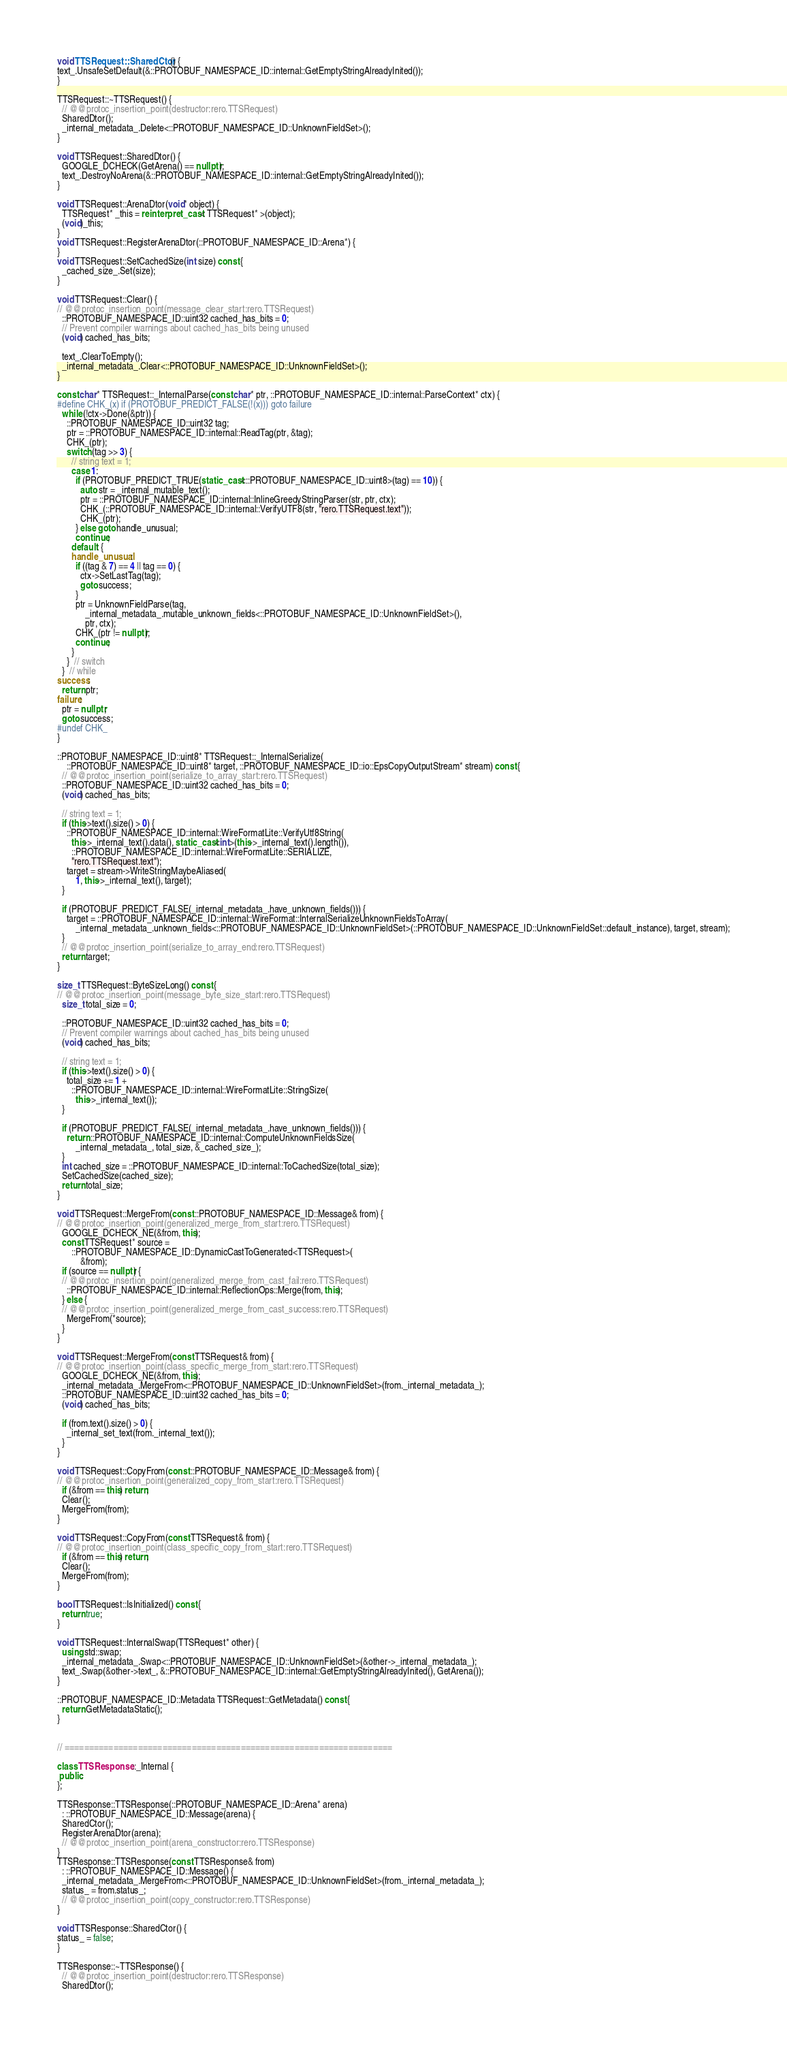Convert code to text. <code><loc_0><loc_0><loc_500><loc_500><_C++_>
void TTSRequest::SharedCtor() {
text_.UnsafeSetDefault(&::PROTOBUF_NAMESPACE_ID::internal::GetEmptyStringAlreadyInited());
}

TTSRequest::~TTSRequest() {
  // @@protoc_insertion_point(destructor:rero.TTSRequest)
  SharedDtor();
  _internal_metadata_.Delete<::PROTOBUF_NAMESPACE_ID::UnknownFieldSet>();
}

void TTSRequest::SharedDtor() {
  GOOGLE_DCHECK(GetArena() == nullptr);
  text_.DestroyNoArena(&::PROTOBUF_NAMESPACE_ID::internal::GetEmptyStringAlreadyInited());
}

void TTSRequest::ArenaDtor(void* object) {
  TTSRequest* _this = reinterpret_cast< TTSRequest* >(object);
  (void)_this;
}
void TTSRequest::RegisterArenaDtor(::PROTOBUF_NAMESPACE_ID::Arena*) {
}
void TTSRequest::SetCachedSize(int size) const {
  _cached_size_.Set(size);
}

void TTSRequest::Clear() {
// @@protoc_insertion_point(message_clear_start:rero.TTSRequest)
  ::PROTOBUF_NAMESPACE_ID::uint32 cached_has_bits = 0;
  // Prevent compiler warnings about cached_has_bits being unused
  (void) cached_has_bits;

  text_.ClearToEmpty();
  _internal_metadata_.Clear<::PROTOBUF_NAMESPACE_ID::UnknownFieldSet>();
}

const char* TTSRequest::_InternalParse(const char* ptr, ::PROTOBUF_NAMESPACE_ID::internal::ParseContext* ctx) {
#define CHK_(x) if (PROTOBUF_PREDICT_FALSE(!(x))) goto failure
  while (!ctx->Done(&ptr)) {
    ::PROTOBUF_NAMESPACE_ID::uint32 tag;
    ptr = ::PROTOBUF_NAMESPACE_ID::internal::ReadTag(ptr, &tag);
    CHK_(ptr);
    switch (tag >> 3) {
      // string text = 1;
      case 1:
        if (PROTOBUF_PREDICT_TRUE(static_cast<::PROTOBUF_NAMESPACE_ID::uint8>(tag) == 10)) {
          auto str = _internal_mutable_text();
          ptr = ::PROTOBUF_NAMESPACE_ID::internal::InlineGreedyStringParser(str, ptr, ctx);
          CHK_(::PROTOBUF_NAMESPACE_ID::internal::VerifyUTF8(str, "rero.TTSRequest.text"));
          CHK_(ptr);
        } else goto handle_unusual;
        continue;
      default: {
      handle_unusual:
        if ((tag & 7) == 4 || tag == 0) {
          ctx->SetLastTag(tag);
          goto success;
        }
        ptr = UnknownFieldParse(tag,
            _internal_metadata_.mutable_unknown_fields<::PROTOBUF_NAMESPACE_ID::UnknownFieldSet>(),
            ptr, ctx);
        CHK_(ptr != nullptr);
        continue;
      }
    }  // switch
  }  // while
success:
  return ptr;
failure:
  ptr = nullptr;
  goto success;
#undef CHK_
}

::PROTOBUF_NAMESPACE_ID::uint8* TTSRequest::_InternalSerialize(
    ::PROTOBUF_NAMESPACE_ID::uint8* target, ::PROTOBUF_NAMESPACE_ID::io::EpsCopyOutputStream* stream) const {
  // @@protoc_insertion_point(serialize_to_array_start:rero.TTSRequest)
  ::PROTOBUF_NAMESPACE_ID::uint32 cached_has_bits = 0;
  (void) cached_has_bits;

  // string text = 1;
  if (this->text().size() > 0) {
    ::PROTOBUF_NAMESPACE_ID::internal::WireFormatLite::VerifyUtf8String(
      this->_internal_text().data(), static_cast<int>(this->_internal_text().length()),
      ::PROTOBUF_NAMESPACE_ID::internal::WireFormatLite::SERIALIZE,
      "rero.TTSRequest.text");
    target = stream->WriteStringMaybeAliased(
        1, this->_internal_text(), target);
  }

  if (PROTOBUF_PREDICT_FALSE(_internal_metadata_.have_unknown_fields())) {
    target = ::PROTOBUF_NAMESPACE_ID::internal::WireFormat::InternalSerializeUnknownFieldsToArray(
        _internal_metadata_.unknown_fields<::PROTOBUF_NAMESPACE_ID::UnknownFieldSet>(::PROTOBUF_NAMESPACE_ID::UnknownFieldSet::default_instance), target, stream);
  }
  // @@protoc_insertion_point(serialize_to_array_end:rero.TTSRequest)
  return target;
}

size_t TTSRequest::ByteSizeLong() const {
// @@protoc_insertion_point(message_byte_size_start:rero.TTSRequest)
  size_t total_size = 0;

  ::PROTOBUF_NAMESPACE_ID::uint32 cached_has_bits = 0;
  // Prevent compiler warnings about cached_has_bits being unused
  (void) cached_has_bits;

  // string text = 1;
  if (this->text().size() > 0) {
    total_size += 1 +
      ::PROTOBUF_NAMESPACE_ID::internal::WireFormatLite::StringSize(
        this->_internal_text());
  }

  if (PROTOBUF_PREDICT_FALSE(_internal_metadata_.have_unknown_fields())) {
    return ::PROTOBUF_NAMESPACE_ID::internal::ComputeUnknownFieldsSize(
        _internal_metadata_, total_size, &_cached_size_);
  }
  int cached_size = ::PROTOBUF_NAMESPACE_ID::internal::ToCachedSize(total_size);
  SetCachedSize(cached_size);
  return total_size;
}

void TTSRequest::MergeFrom(const ::PROTOBUF_NAMESPACE_ID::Message& from) {
// @@protoc_insertion_point(generalized_merge_from_start:rero.TTSRequest)
  GOOGLE_DCHECK_NE(&from, this);
  const TTSRequest* source =
      ::PROTOBUF_NAMESPACE_ID::DynamicCastToGenerated<TTSRequest>(
          &from);
  if (source == nullptr) {
  // @@protoc_insertion_point(generalized_merge_from_cast_fail:rero.TTSRequest)
    ::PROTOBUF_NAMESPACE_ID::internal::ReflectionOps::Merge(from, this);
  } else {
  // @@protoc_insertion_point(generalized_merge_from_cast_success:rero.TTSRequest)
    MergeFrom(*source);
  }
}

void TTSRequest::MergeFrom(const TTSRequest& from) {
// @@protoc_insertion_point(class_specific_merge_from_start:rero.TTSRequest)
  GOOGLE_DCHECK_NE(&from, this);
  _internal_metadata_.MergeFrom<::PROTOBUF_NAMESPACE_ID::UnknownFieldSet>(from._internal_metadata_);
  ::PROTOBUF_NAMESPACE_ID::uint32 cached_has_bits = 0;
  (void) cached_has_bits;

  if (from.text().size() > 0) {
    _internal_set_text(from._internal_text());
  }
}

void TTSRequest::CopyFrom(const ::PROTOBUF_NAMESPACE_ID::Message& from) {
// @@protoc_insertion_point(generalized_copy_from_start:rero.TTSRequest)
  if (&from == this) return;
  Clear();
  MergeFrom(from);
}

void TTSRequest::CopyFrom(const TTSRequest& from) {
// @@protoc_insertion_point(class_specific_copy_from_start:rero.TTSRequest)
  if (&from == this) return;
  Clear();
  MergeFrom(from);
}

bool TTSRequest::IsInitialized() const {
  return true;
}

void TTSRequest::InternalSwap(TTSRequest* other) {
  using std::swap;
  _internal_metadata_.Swap<::PROTOBUF_NAMESPACE_ID::UnknownFieldSet>(&other->_internal_metadata_);
  text_.Swap(&other->text_, &::PROTOBUF_NAMESPACE_ID::internal::GetEmptyStringAlreadyInited(), GetArena());
}

::PROTOBUF_NAMESPACE_ID::Metadata TTSRequest::GetMetadata() const {
  return GetMetadataStatic();
}


// ===================================================================

class TTSResponse::_Internal {
 public:
};

TTSResponse::TTSResponse(::PROTOBUF_NAMESPACE_ID::Arena* arena)
  : ::PROTOBUF_NAMESPACE_ID::Message(arena) {
  SharedCtor();
  RegisterArenaDtor(arena);
  // @@protoc_insertion_point(arena_constructor:rero.TTSResponse)
}
TTSResponse::TTSResponse(const TTSResponse& from)
  : ::PROTOBUF_NAMESPACE_ID::Message() {
  _internal_metadata_.MergeFrom<::PROTOBUF_NAMESPACE_ID::UnknownFieldSet>(from._internal_metadata_);
  status_ = from.status_;
  // @@protoc_insertion_point(copy_constructor:rero.TTSResponse)
}

void TTSResponse::SharedCtor() {
status_ = false;
}

TTSResponse::~TTSResponse() {
  // @@protoc_insertion_point(destructor:rero.TTSResponse)
  SharedDtor();</code> 